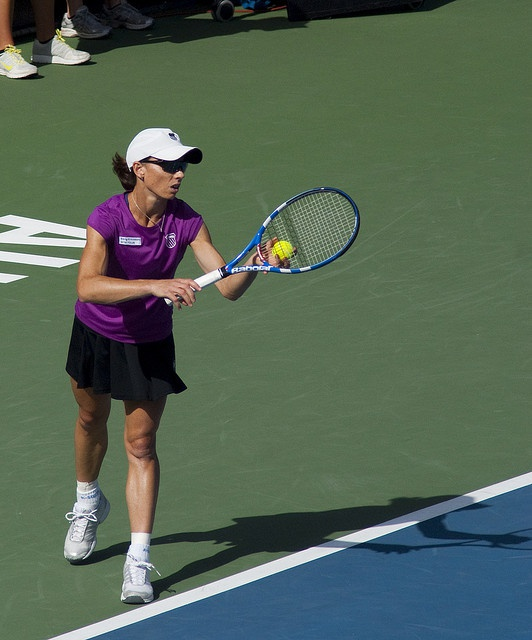Describe the objects in this image and their specific colors. I can see people in salmon, black, gray, and lightgray tones, tennis racket in salmon, gray, darkgray, and black tones, people in salmon, black, lightgray, darkgray, and beige tones, people in salmon, black, gray, and darkgray tones, and sports ball in salmon, yellow, olive, and khaki tones in this image. 